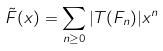Convert formula to latex. <formula><loc_0><loc_0><loc_500><loc_500>\tilde { F } ( x ) = \sum _ { n \geq 0 } | T ( F _ { n } ) | x ^ { n }</formula> 